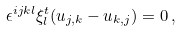<formula> <loc_0><loc_0><loc_500><loc_500>\epsilon ^ { i j k l } \xi _ { l } ^ { t } ( u _ { j , k } - u _ { k , j } ) = 0 \, ,</formula> 